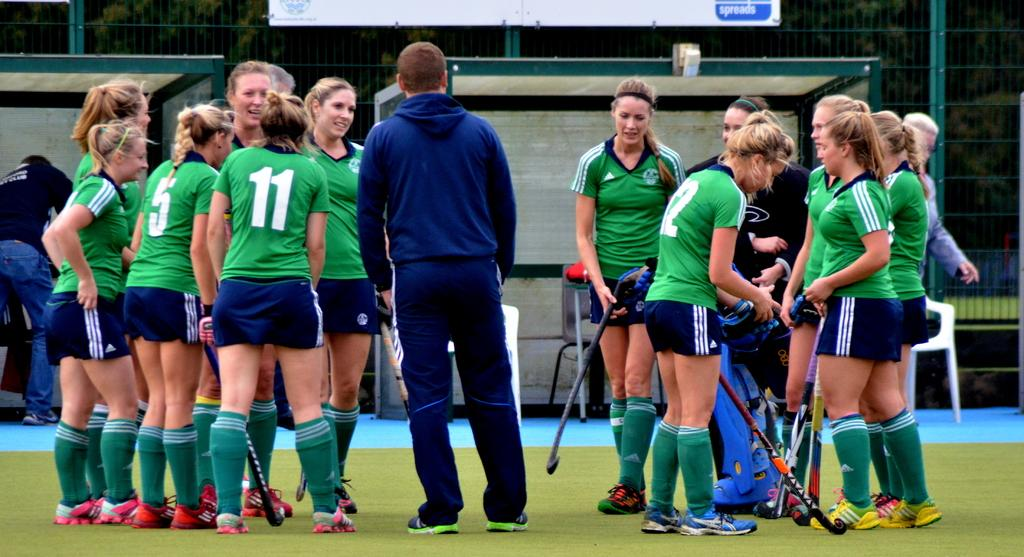<image>
Write a terse but informative summary of the picture. The players in the green jerseys include numbers 5 and 11. 